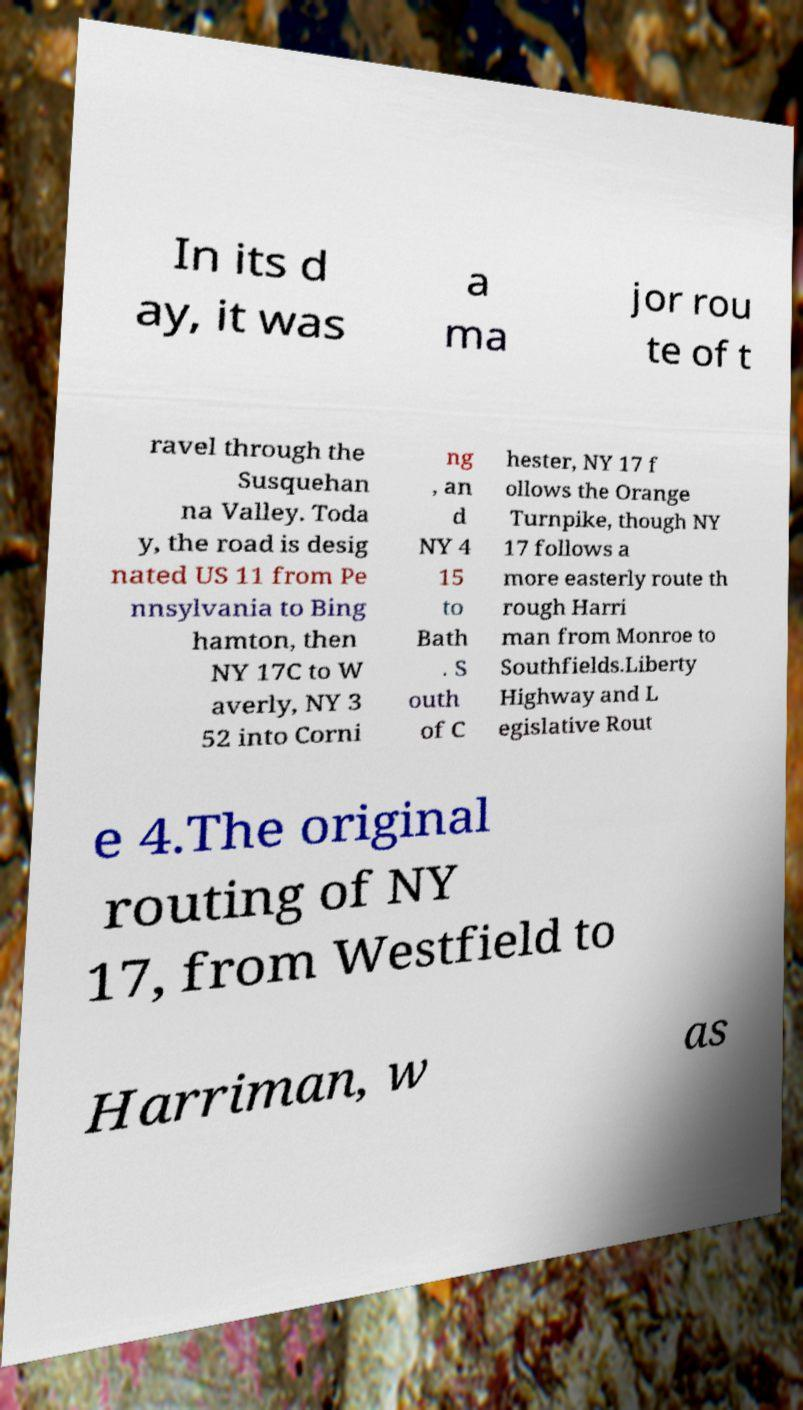Please identify and transcribe the text found in this image. In its d ay, it was a ma jor rou te of t ravel through the Susquehan na Valley. Toda y, the road is desig nated US 11 from Pe nnsylvania to Bing hamton, then NY 17C to W averly, NY 3 52 into Corni ng , an d NY 4 15 to Bath . S outh of C hester, NY 17 f ollows the Orange Turnpike, though NY 17 follows a more easterly route th rough Harri man from Monroe to Southfields.Liberty Highway and L egislative Rout e 4.The original routing of NY 17, from Westfield to Harriman, w as 